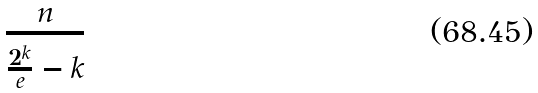Convert formula to latex. <formula><loc_0><loc_0><loc_500><loc_500>\frac { n } { \frac { 2 ^ { k } } { e } - k }</formula> 